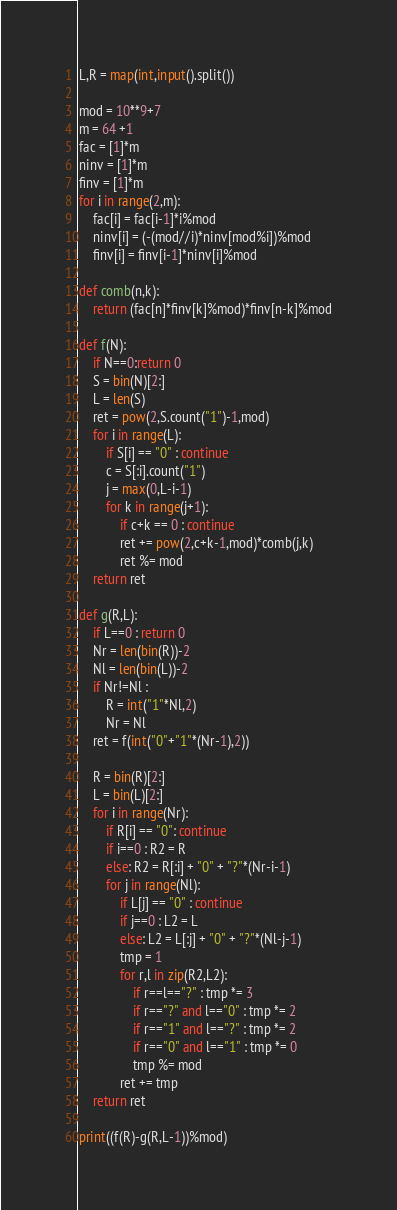<code> <loc_0><loc_0><loc_500><loc_500><_Python_>L,R = map(int,input().split())

mod = 10**9+7
m = 64 +1
fac = [1]*m
ninv = [1]*m
finv = [1]*m
for i in range(2,m):
    fac[i] = fac[i-1]*i%mod
    ninv[i] = (-(mod//i)*ninv[mod%i])%mod
    finv[i] = finv[i-1]*ninv[i]%mod

def comb(n,k):
    return (fac[n]*finv[k]%mod)*finv[n-k]%mod

def f(N):
    if N==0:return 0
    S = bin(N)[2:]
    L = len(S)
    ret = pow(2,S.count("1")-1,mod)
    for i in range(L):
        if S[i] == "0" : continue
        c = S[:i].count("1")
        j = max(0,L-i-1)
        for k in range(j+1):
            if c+k == 0 : continue
            ret += pow(2,c+k-1,mod)*comb(j,k)
            ret %= mod
    return ret

def g(R,L):
    if L==0 : return 0
    Nr = len(bin(R))-2
    Nl = len(bin(L))-2
    if Nr!=Nl :
        R = int("1"*Nl,2)
        Nr = Nl
    ret = f(int("0"+"1"*(Nr-1),2))
    
    R = bin(R)[2:]
    L = bin(L)[2:]
    for i in range(Nr):
        if R[i] == "0": continue
        if i==0 : R2 = R
        else: R2 = R[:i] + "0" + "?"*(Nr-i-1)
        for j in range(Nl):
            if L[j] == "0" : continue
            if j==0 : L2 = L
            else: L2 = L[:j] + "0" + "?"*(Nl-j-1)
            tmp = 1
            for r,l in zip(R2,L2):
                if r==l=="?" : tmp *= 3
                if r=="?" and l=="0" : tmp *= 2
                if r=="1" and l=="?" : tmp *= 2
                if r=="0" and l=="1" : tmp *= 0
                tmp %= mod
            ret += tmp
    return ret

print((f(R)-g(R,L-1))%mod)</code> 